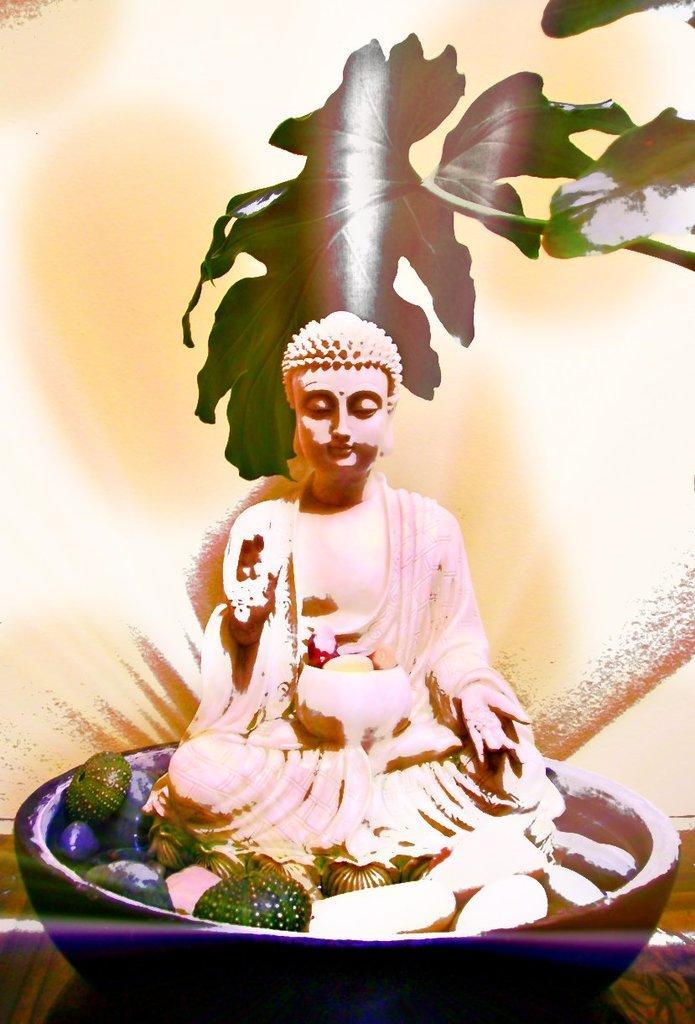Describe this image in one or two sentences. In this image there is an object on the ground, there is a statue of Lord Buddha, there are leaves truncated towards the right of the image, there is an object truncated towards the right of the image, the background of the image is orange in color. 